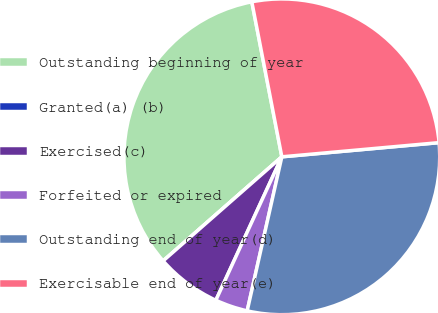Convert chart. <chart><loc_0><loc_0><loc_500><loc_500><pie_chart><fcel>Outstanding beginning of year<fcel>Granted(a) (b)<fcel>Exercised(c)<fcel>Forfeited or expired<fcel>Outstanding end of year(d)<fcel>Exercisable end of year(e)<nl><fcel>33.41%<fcel>0.0%<fcel>6.68%<fcel>3.34%<fcel>29.95%<fcel>26.61%<nl></chart> 